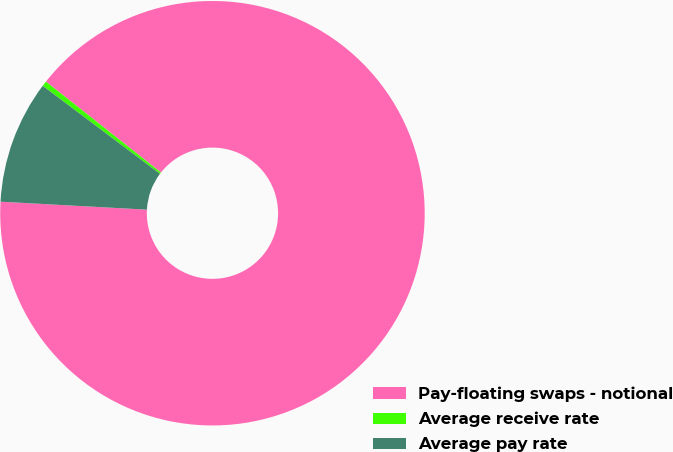Convert chart. <chart><loc_0><loc_0><loc_500><loc_500><pie_chart><fcel>Pay-floating swaps - notional<fcel>Average receive rate<fcel>Average pay rate<nl><fcel>90.22%<fcel>0.4%<fcel>9.38%<nl></chart> 